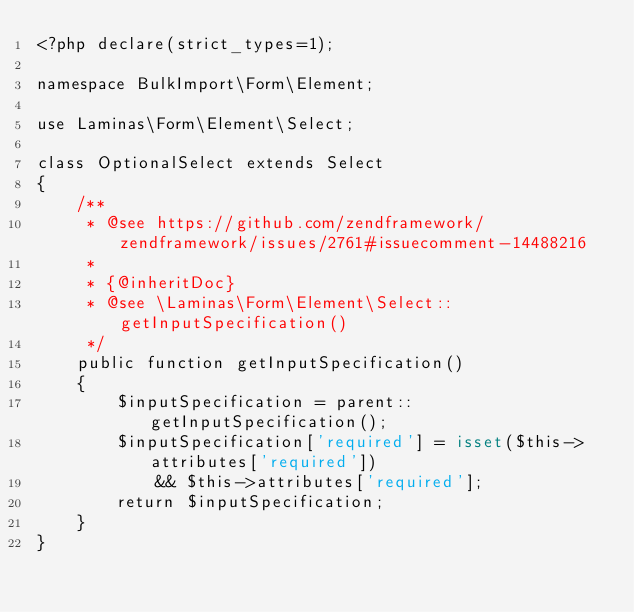<code> <loc_0><loc_0><loc_500><loc_500><_PHP_><?php declare(strict_types=1);

namespace BulkImport\Form\Element;

use Laminas\Form\Element\Select;

class OptionalSelect extends Select
{
    /**
     * @see https://github.com/zendframework/zendframework/issues/2761#issuecomment-14488216
     *
     * {@inheritDoc}
     * @see \Laminas\Form\Element\Select::getInputSpecification()
     */
    public function getInputSpecification()
    {
        $inputSpecification = parent::getInputSpecification();
        $inputSpecification['required'] = isset($this->attributes['required'])
            && $this->attributes['required'];
        return $inputSpecification;
    }
}
</code> 